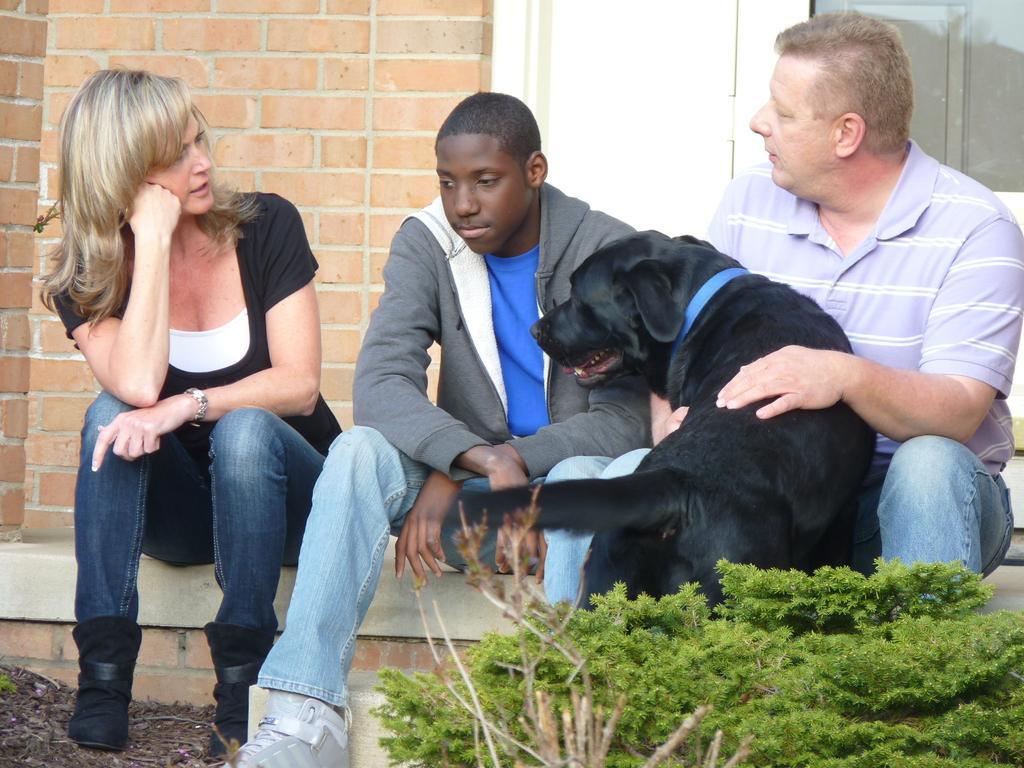Please provide a concise description of this image. In this image I can see three people with the dog. In front of them there is a plant. In the background there is a wall. 